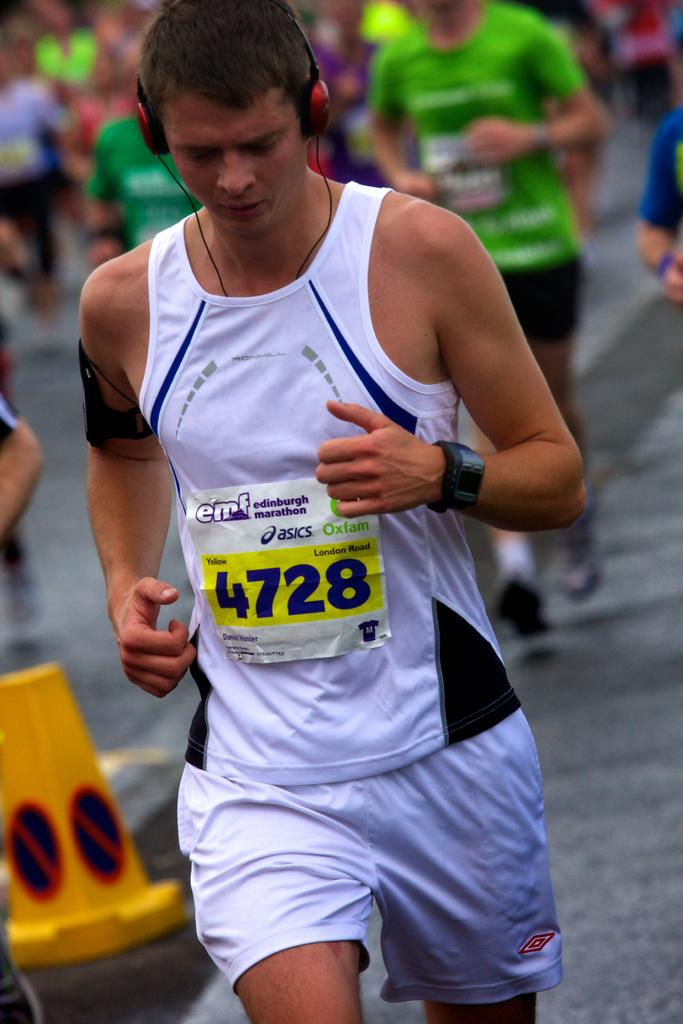<image>
Provide a brief description of the given image. A man wearing a Edinburgh Marathon shirt with the number 4728 on the front. 